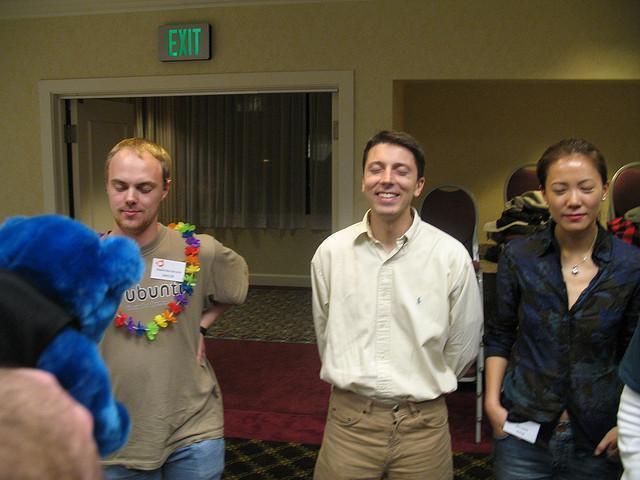How many women in the photo?
Give a very brief answer. 1. How many people are there?
Give a very brief answer. 5. How many white stuffed bears are there?
Give a very brief answer. 0. 